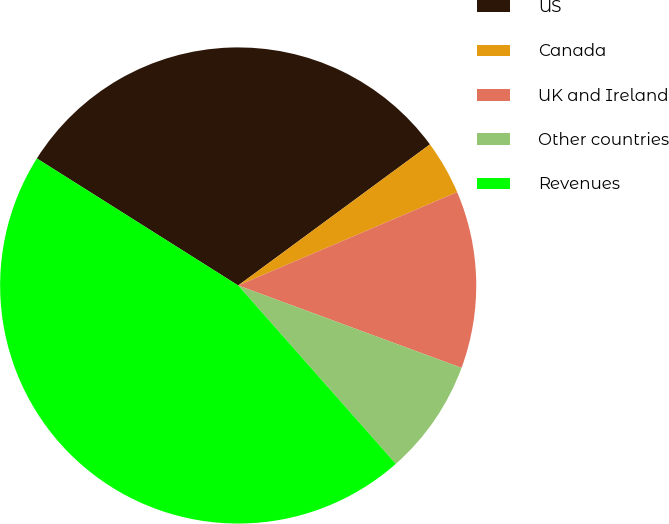Convert chart to OTSL. <chart><loc_0><loc_0><loc_500><loc_500><pie_chart><fcel>US<fcel>Canada<fcel>UK and Ireland<fcel>Other countries<fcel>Revenues<nl><fcel>30.95%<fcel>3.68%<fcel>12.04%<fcel>7.86%<fcel>45.48%<nl></chart> 